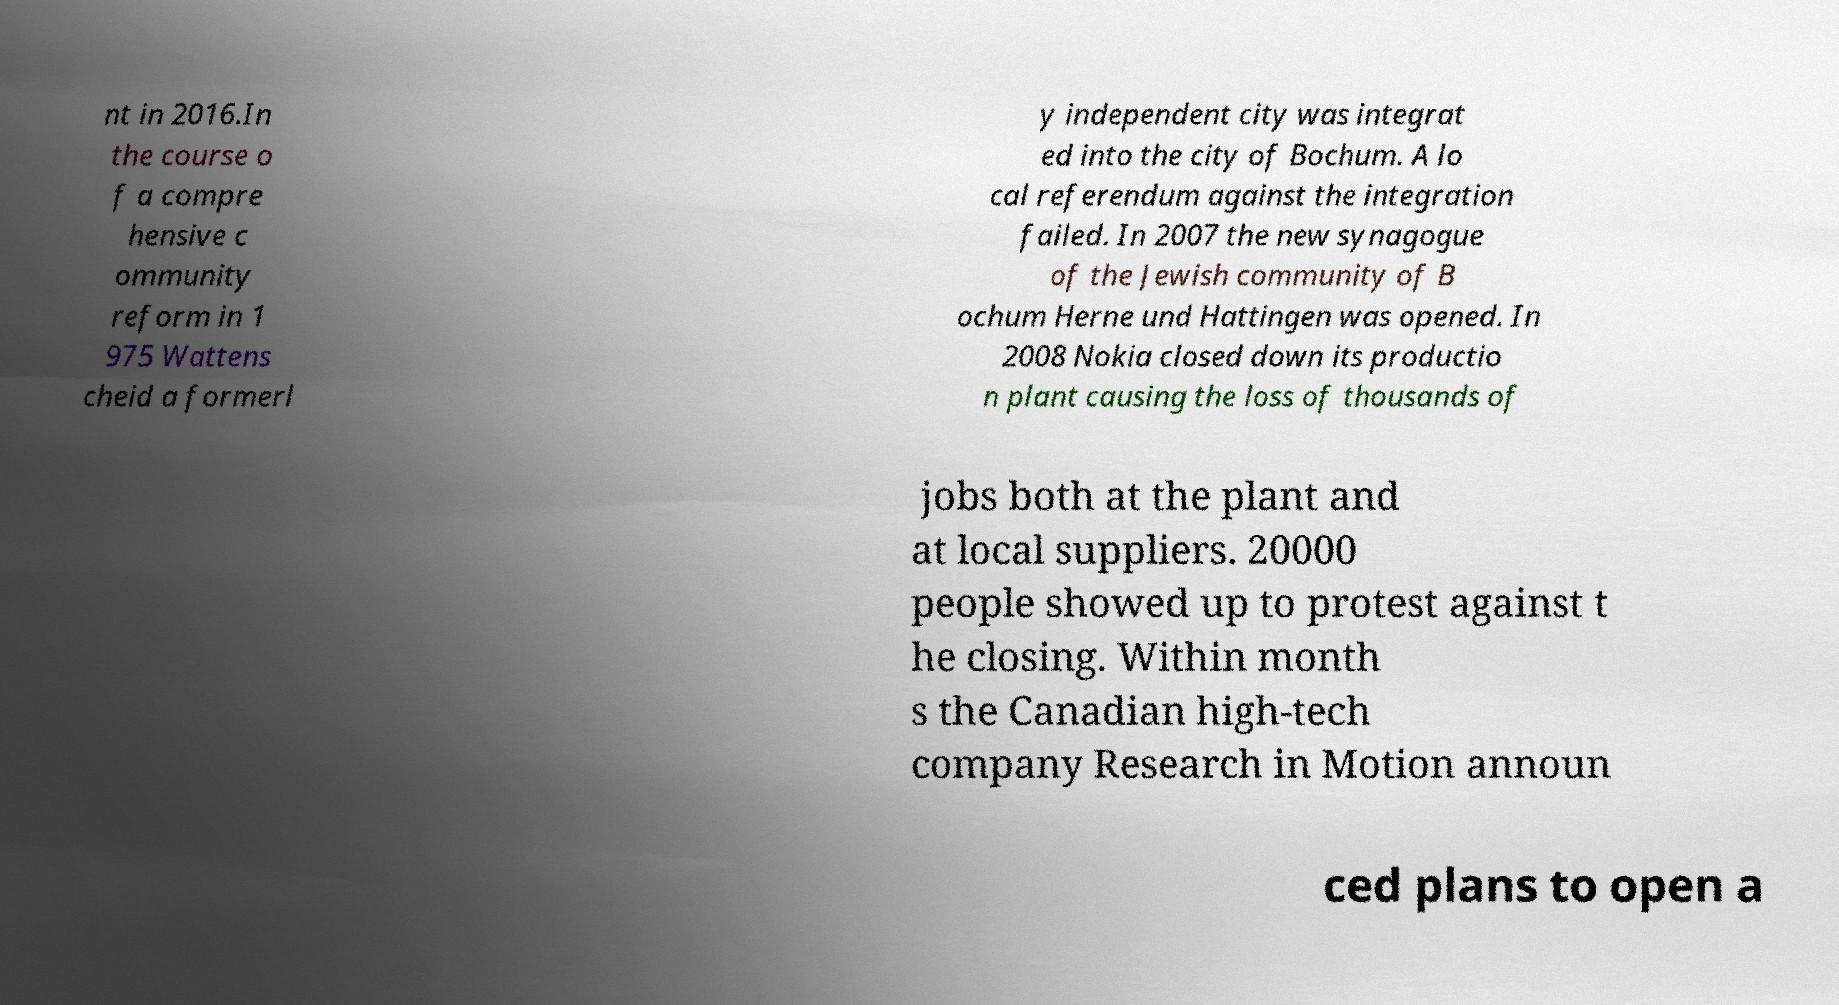Can you accurately transcribe the text from the provided image for me? nt in 2016.In the course o f a compre hensive c ommunity reform in 1 975 Wattens cheid a formerl y independent city was integrat ed into the city of Bochum. A lo cal referendum against the integration failed. In 2007 the new synagogue of the Jewish community of B ochum Herne und Hattingen was opened. In 2008 Nokia closed down its productio n plant causing the loss of thousands of jobs both at the plant and at local suppliers. 20000 people showed up to protest against t he closing. Within month s the Canadian high-tech company Research in Motion announ ced plans to open a 